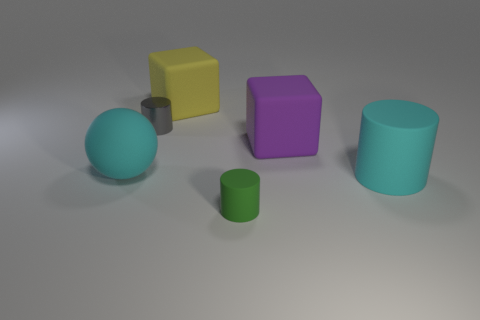Is the color of the large matte cylinder the same as the matte ball?
Ensure brevity in your answer.  Yes. There is a green object that is made of the same material as the big yellow object; what is its size?
Offer a very short reply. Small. Are there any tiny gray metal cylinders in front of the small gray cylinder?
Your answer should be very brief. No. There is a cylinder behind the big purple rubber cube; is there a large cyan ball that is behind it?
Offer a terse response. No. There is a matte cube that is on the left side of the tiny green cylinder; does it have the same size as the matte cube in front of the yellow matte cube?
Give a very brief answer. Yes. How many large objects are either green matte things or blocks?
Keep it short and to the point. 2. There is a cyan object left of the tiny cylinder right of the small gray object; what is its material?
Give a very brief answer. Rubber. What is the shape of the big rubber object that is the same color as the matte ball?
Your response must be concise. Cylinder. Is there a green thing made of the same material as the big purple block?
Your answer should be compact. Yes. Are the large cylinder and the cyan thing that is to the left of the big rubber cylinder made of the same material?
Provide a succinct answer. Yes. 